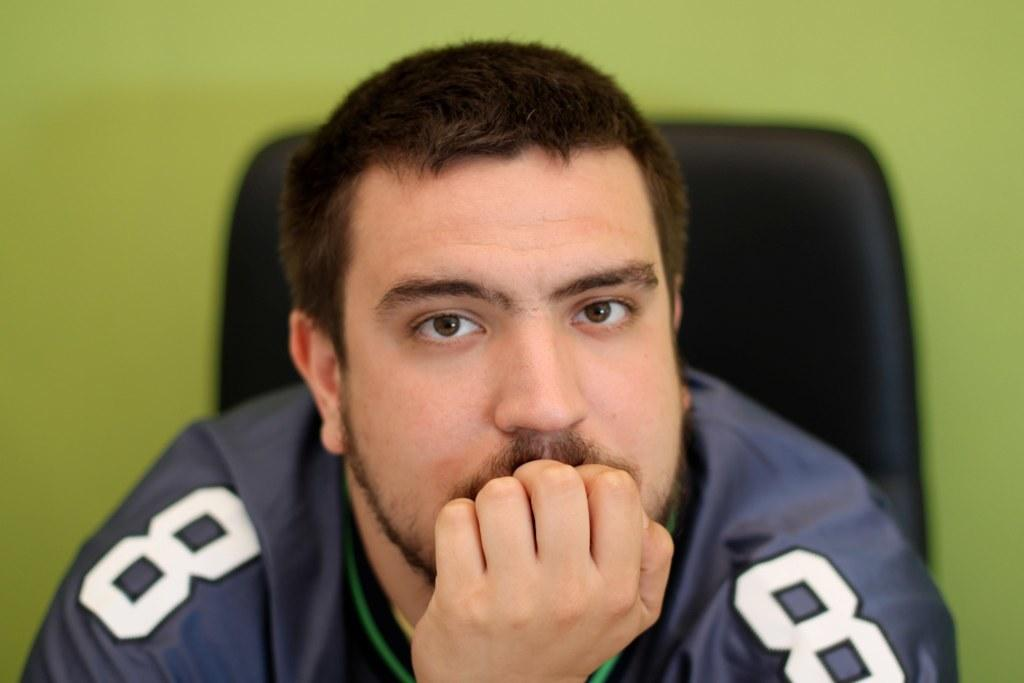<image>
Create a compact narrative representing the image presented. A man rests his head on his fist and is wearing a jersey with the number 8 on the sleeves. 